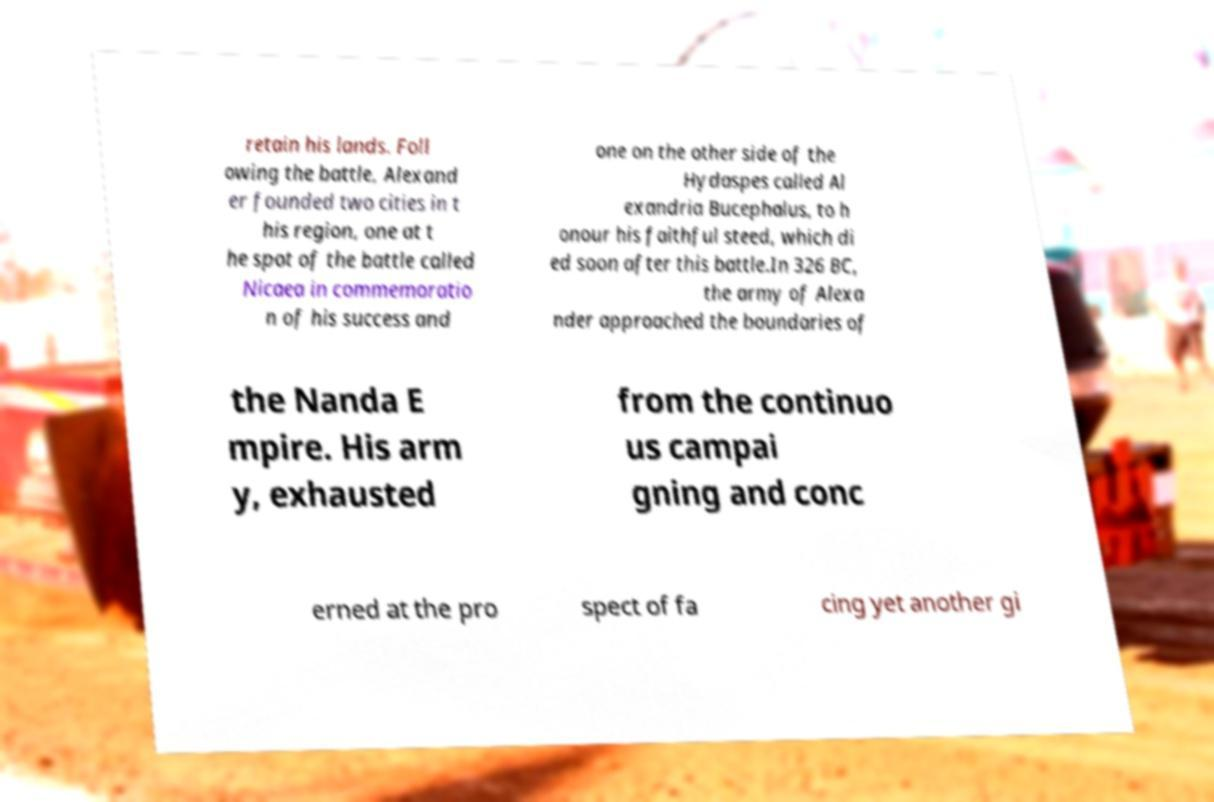I need the written content from this picture converted into text. Can you do that? retain his lands. Foll owing the battle, Alexand er founded two cities in t his region, one at t he spot of the battle called Nicaea in commemoratio n of his success and one on the other side of the Hydaspes called Al exandria Bucephalus, to h onour his faithful steed, which di ed soon after this battle.In 326 BC, the army of Alexa nder approached the boundaries of the Nanda E mpire. His arm y, exhausted from the continuo us campai gning and conc erned at the pro spect of fa cing yet another gi 